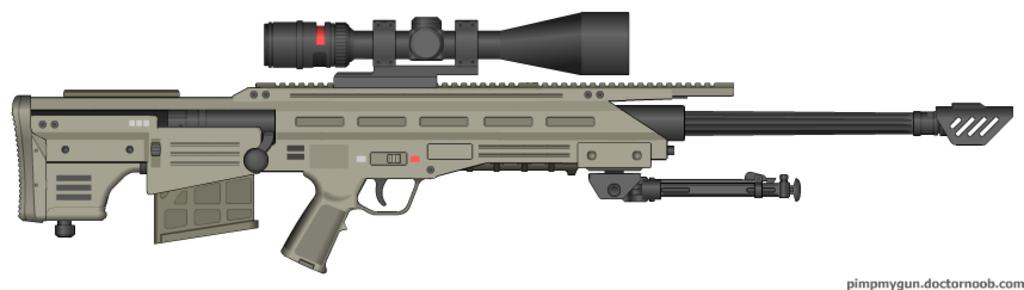What object is present in the image? There is a gun in the image. What is the color of the gun? The gun is gray in color. What type of light can be seen reflecting off the square sleet in the image? There is no mention of square sleet or any light source in the image, as it only features a gray gun. 